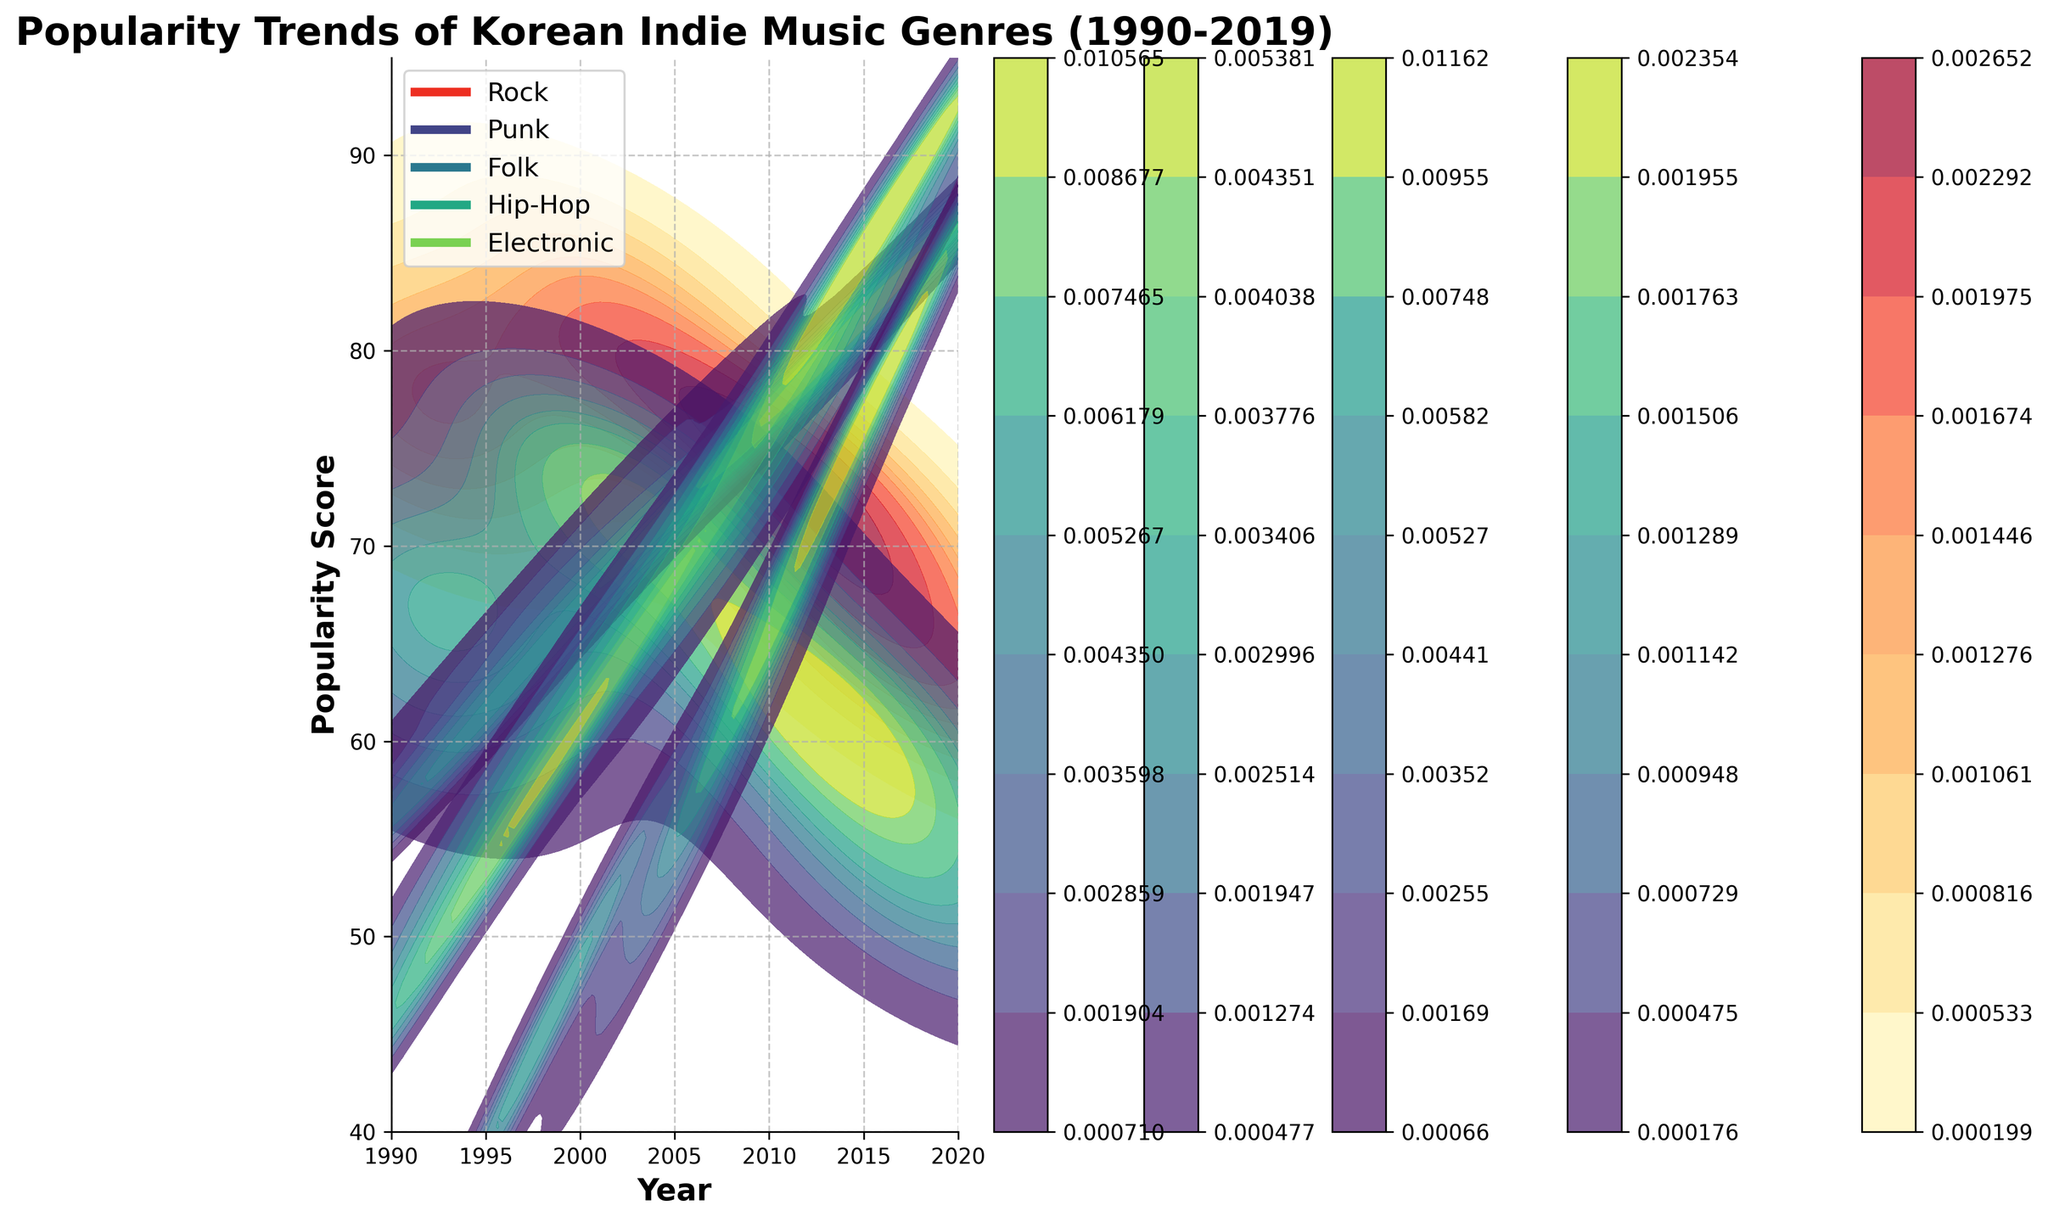What is the title of the plot? The title of the plot is usually located at the top. In this case, you can find the plot's title at the top center of the figure.
Answer: Popularity Trends of Korean Indie Music Genres (1990-2019) What does the x-axis represent? The x-axis is labeled towards the bottom of the plot and usually describes what is being measured along that axis. In this figure, the x-axis represents the years in the timeframe being analyzed.
Answer: Year Which genre had the highest peak in popularity score around the year 2014? The density plot will show shaded areas indicating the popularity scores of genres over time. By visually inspecting the figure, we can see that the highest peak around 2014 is in the Hip-Hop section.
Answer: Hip-Hop Compare the popularity trend of Rock and Punk genres between 1990 and 2000. Look at the density areas for Rock and Punk from 1990 to 2000. Rock seems to have a generally higher popularity score and more density area compared to Punk in the same period.
Answer: Rock was more popular than Punk between 1990 and 2000 How did the popularity score of Folk change from 2010 to 2019? Observe the shaded area of the Folk genre from 2010 to 2019. The density plot will show an increase in the shaded area's height, indicating higher popularity scores over these years.
Answer: Increased From which year did Electronic music start rising in popularity? By looking at the density areas, you can identify where the shaded area for Electronic music begins to increase. This is around the mid-to-late 1990s.
Answer: Around 1996 Which two genres had the closest popularity scores around 2005? Check the density plot around the year 2005. Look for the shaded areas that are close to each other in terms of popularity scores. Rock and Punk scores appear to be quite close in that timeframe.
Answer: Rock and Punk By how much did the popularity score of Hip-Hop increase from 2010 to 2019? By looking at the shaded area for Hip-Hop from 2010 to 2019, observe the change in peak popularity score from approximately 72 in 2010 to about 91 in 2019. The difference is 91 - 72.
Answer: 19 points In the period from 1990 to 1995, which genre saw the least growth in popularity score? Compare the shaded areas of all genres from 1990 to 1995. The genre with the flattest slope or least increase in density is Hip-Hop.
Answer: Hip-Hop Which genre had the most consistent increase in popularity over time? Look for the genre with a generally steady upward trend in the popularity score over the entire period. Folk shows a consistent increase in popularity without any major dips or fluctuations.
Answer: Folk 